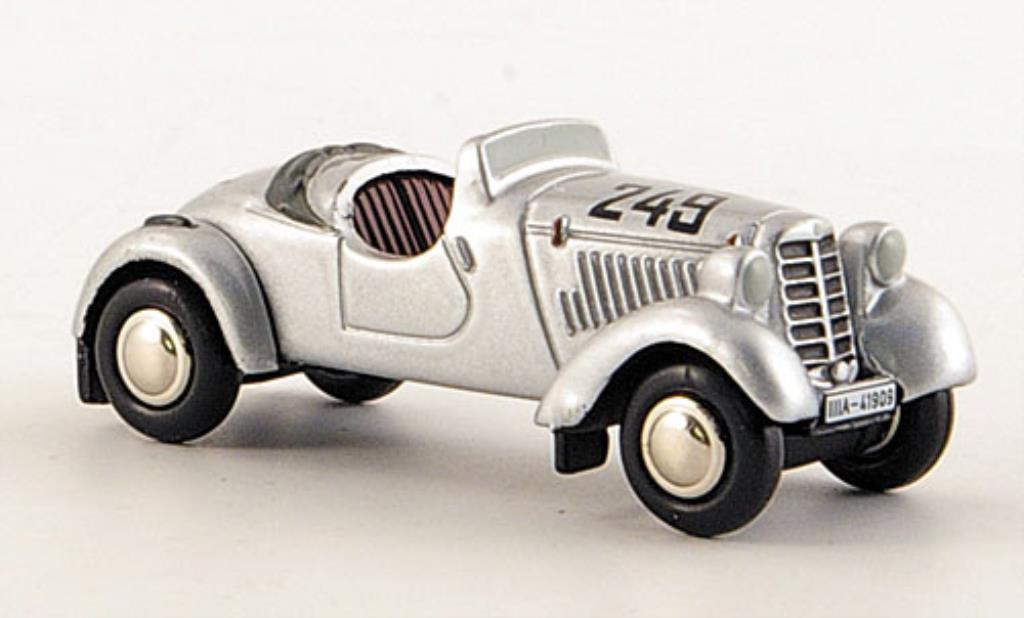Imagine this car has a background story where it participated in a groundbreaking race. Describe that race. On the dusty plains of a historic racetrack in 1935, this car, bearing the number '243', roared to life. It was the era's groundbreaking endurance race, attracting the best racers from across the globe. The race was a grueling test of speed and stamina, set against the backdrop of evolving automotive technology. As '243' sped down the track, it faced fierce competition, jostling for position with other streamlined beauties. With its skilled driver, it maneuvered sharp turns and treacherous straights, ultimately breaking records for average speed and endurance. This race marked a pivotal moment in racing history, showcasing the advancements and daring spirit of the 1930s automotive world. 